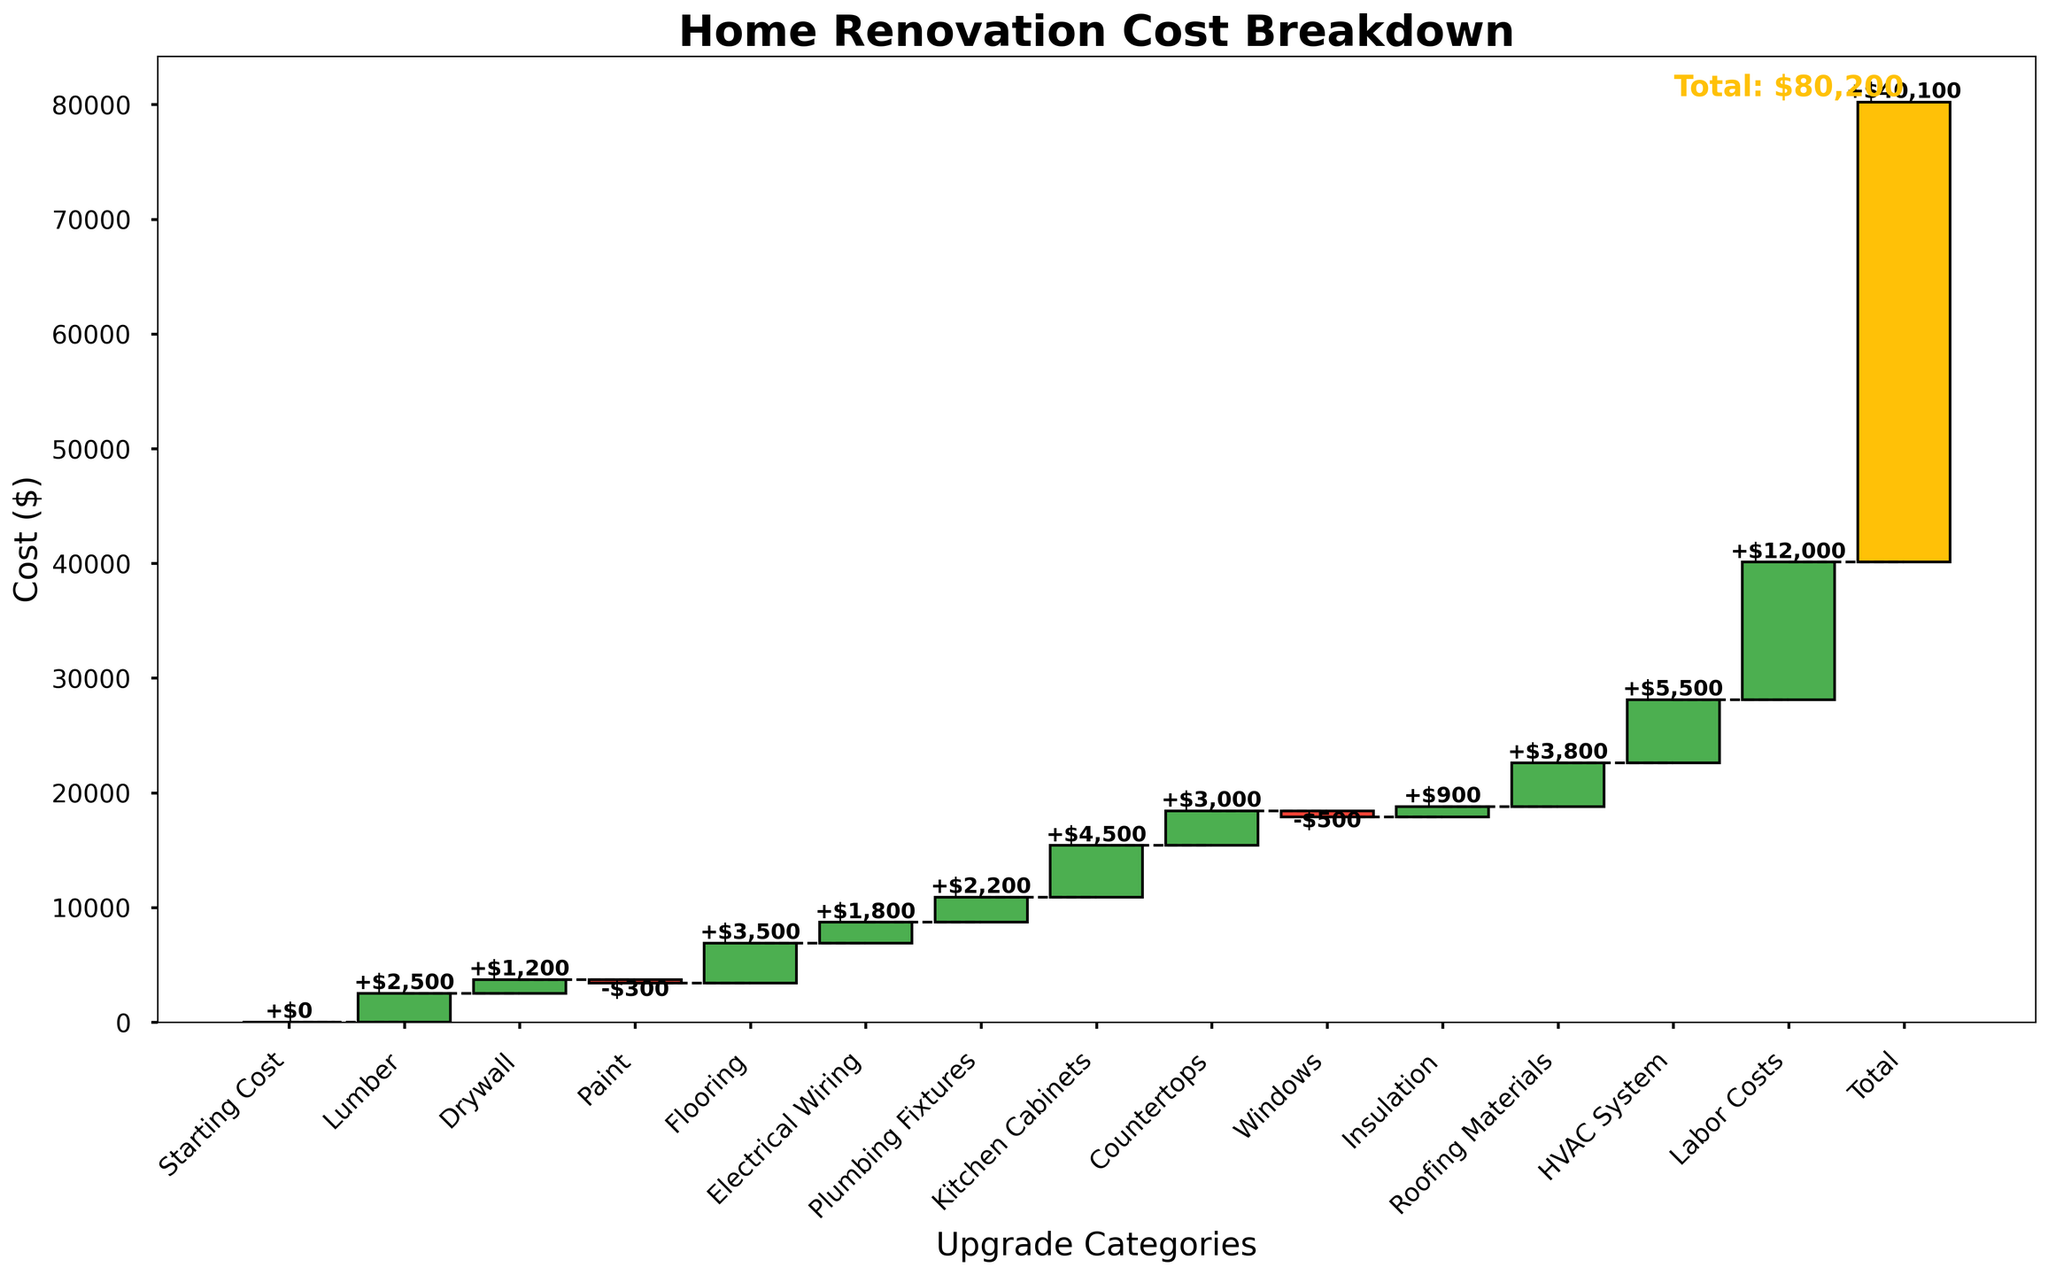What is the title of the chart? The title of the chart is located at the top and provides a summary of what the chart represents. It reads "Home Renovation Cost Breakdown."
Answer: Home Renovation Cost Breakdown How many upgrade categories are there in the chart? By counting the distinct categories listed along the x-axis of the chart, we can determine the number of upgrade categories. There are 13 categories excluding the Starting Cost and Total.
Answer: 13 What is the total cost of home renovation? The total cost is displayed at the end of the chart and indicated in both the bar and the text "Total: $40,100."
Answer: $40,100 Which category has the highest cost and what is its value? By visually scanning the heights of the bars, we can identify the category with the highest cost. The "Labor Costs" category has the highest bar. The value shown at the top of this bar is $12,000.
Answer: Labor Costs, $12,000 How much did the lumber cost? Find the bar labeled "Lumber" and read the value displayed at the top or inside the bar, which is $2,500.
Answer: $2,500 How much did the paint cost? The "Paint" category shows a negative cost, indicating a deduction. The value displayed is -$300.
Answer: -$300 What is the cumulative cost after the plumbing fixtures? The cumulative cost is the sum from the "Starting Cost" up to "Plumbing Fixtures." By adding the values sequentially (0 + 2500 + 1200 - 300 + 3500 + 1800 + 2200), we get the cumulative value of 11,900.
Answer: $11,900 Which categories have negative costs? Visually identify the bars that are colored differently (here, red) and denote negative values. These are "Paint" and "Windows."
Answer: Paint and Windows What is the combined cost of Kitchen Cabinets and Countertops? Sum the values of the specified categories, "Kitchen Cabinets" and "Countertops”: $4,500 + $3,000 = $7,500.
Answer: $7,500 Between Electrical Wiring and HVAC System, which one has a higher cost? Compare the heights and values indicated for "Electrical Wiring" and "HVAC System." The HVAC System has a higher value at $5,500 compared to Electrical Wiring at $1,800.
Answer: HVAC System 